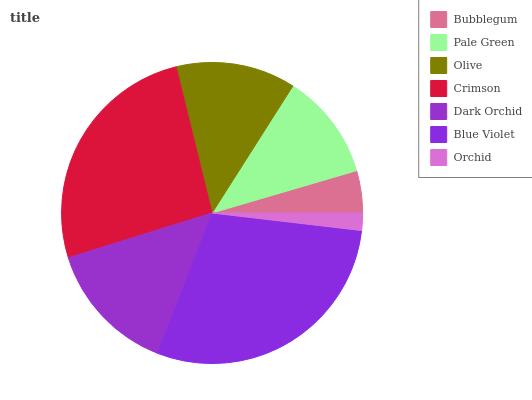Is Orchid the minimum?
Answer yes or no. Yes. Is Blue Violet the maximum?
Answer yes or no. Yes. Is Pale Green the minimum?
Answer yes or no. No. Is Pale Green the maximum?
Answer yes or no. No. Is Pale Green greater than Bubblegum?
Answer yes or no. Yes. Is Bubblegum less than Pale Green?
Answer yes or no. Yes. Is Bubblegum greater than Pale Green?
Answer yes or no. No. Is Pale Green less than Bubblegum?
Answer yes or no. No. Is Olive the high median?
Answer yes or no. Yes. Is Olive the low median?
Answer yes or no. Yes. Is Blue Violet the high median?
Answer yes or no. No. Is Crimson the low median?
Answer yes or no. No. 